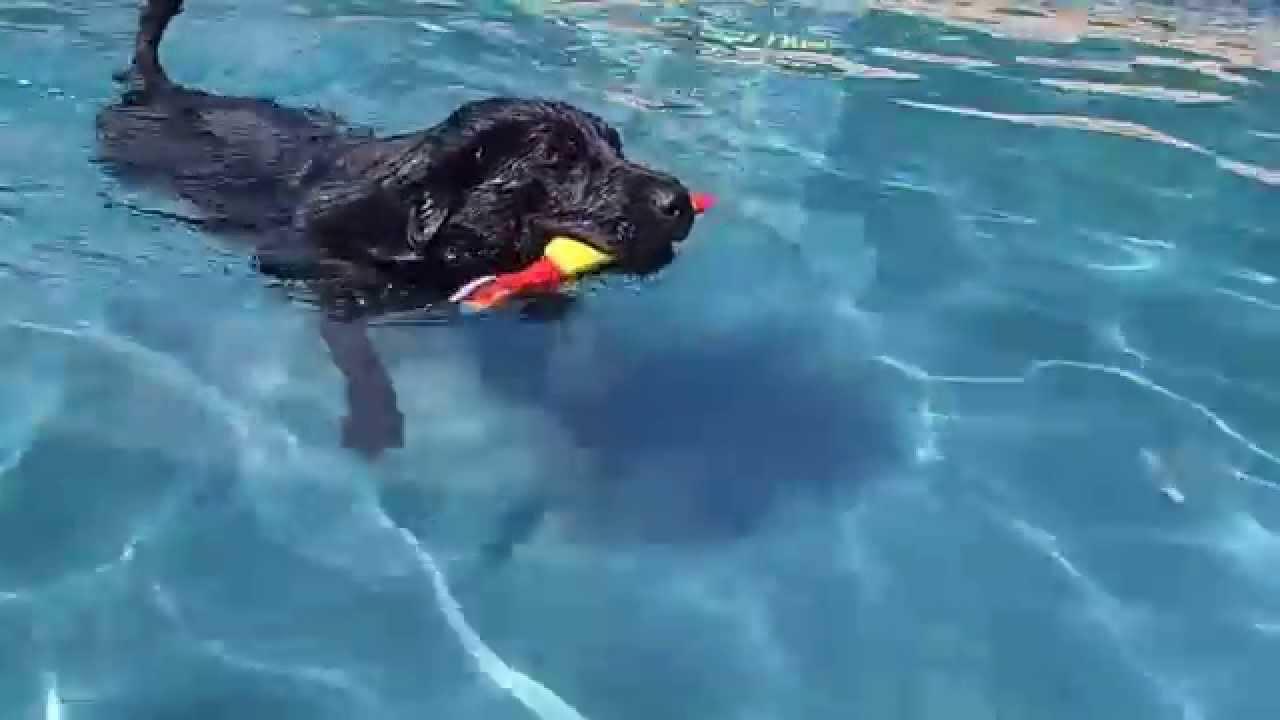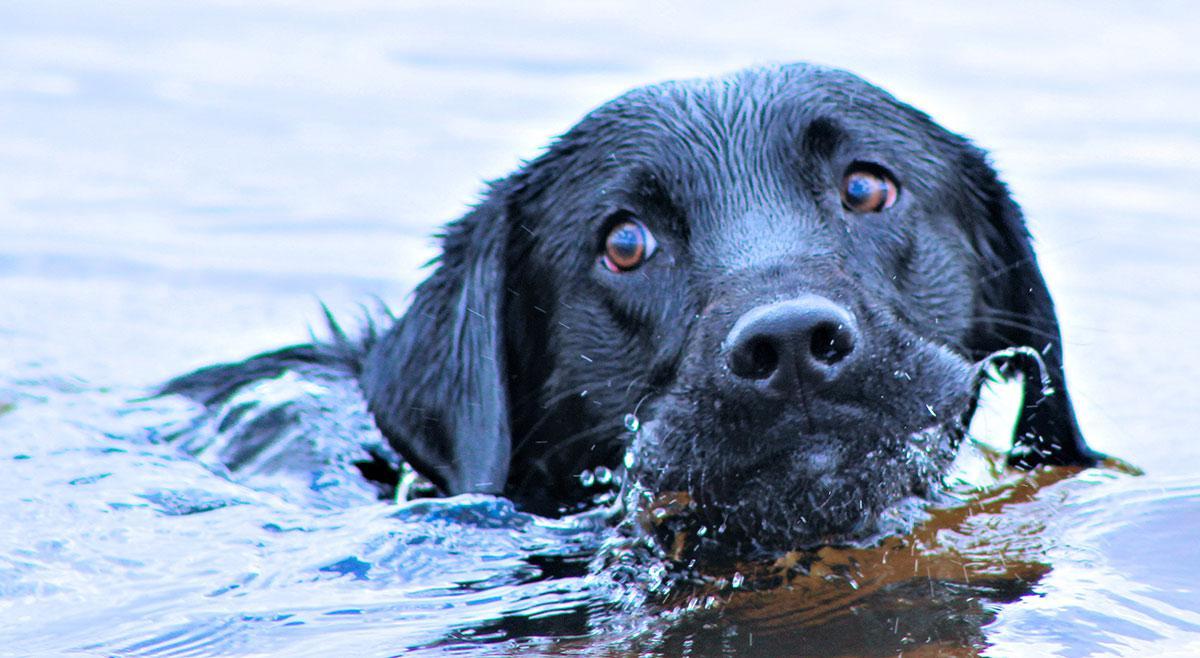The first image is the image on the left, the second image is the image on the right. For the images shown, is this caption "An image shows a swimming dog carrying a stick-shaped object in its mouth." true? Answer yes or no. Yes. The first image is the image on the left, the second image is the image on the right. Assess this claim about the two images: "The dog in the image on the left is swimming with a rod in its mouth.". Correct or not? Answer yes or no. Yes. 